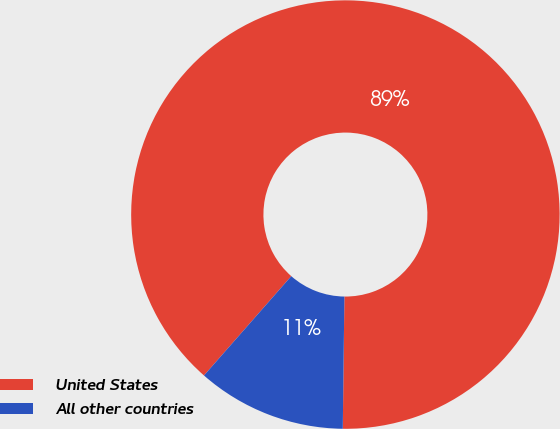Convert chart. <chart><loc_0><loc_0><loc_500><loc_500><pie_chart><fcel>United States<fcel>All other countries<nl><fcel>88.72%<fcel>11.28%<nl></chart> 